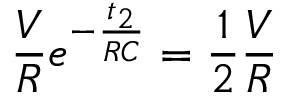Convert formula to latex. <formula><loc_0><loc_0><loc_500><loc_500>\frac { V } { R } e ^ { - \frac { t _ { 2 } } { R C } } = \frac { 1 } { 2 } \frac { V } { R }</formula> 